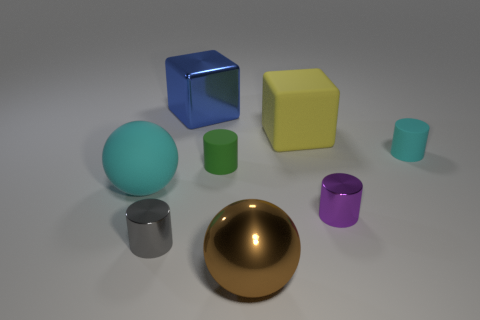What colors are visible in the image, and which color is least represented? The visible colors are blue, yellow, green, cyan, silver, purple, and gold. The least represented color is gold, with only one golden hemisphere present. 